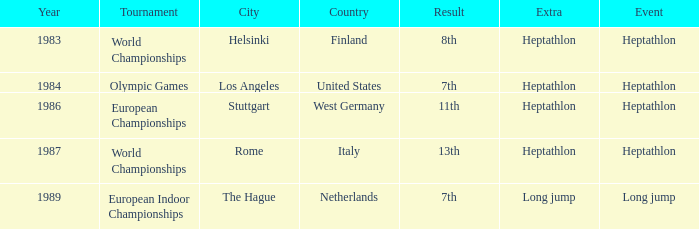Could you parse the entire table? {'header': ['Year', 'Tournament', 'City', 'Country', 'Result', 'Extra', 'Event'], 'rows': [['1983', 'World Championships', 'Helsinki', 'Finland', '8th', 'Heptathlon', 'Heptathlon'], ['1984', 'Olympic Games', 'Los Angeles', 'United States', '7th', 'Heptathlon', 'Heptathlon'], ['1986', 'European Championships', 'Stuttgart', 'West Germany', '11th', 'Heptathlon', 'Heptathlon'], ['1987', 'World Championships', 'Rome', 'Italy', '13th', 'Heptathlon', 'Heptathlon'], ['1989', 'European Indoor Championships', 'The Hague', 'Netherlands', '7th', 'Long jump', 'Long jump']]} How often are the Olympic games hosted? 1984.0. 